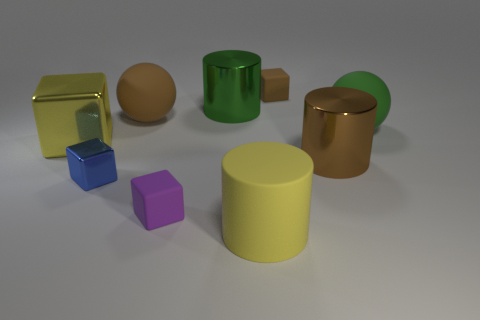Describe the lighting in the scene. The lighting is soft and diffused, originating from the upper left side, casting gentle shadows towards the right, which gives the scene a calm and balanced ambiance. 